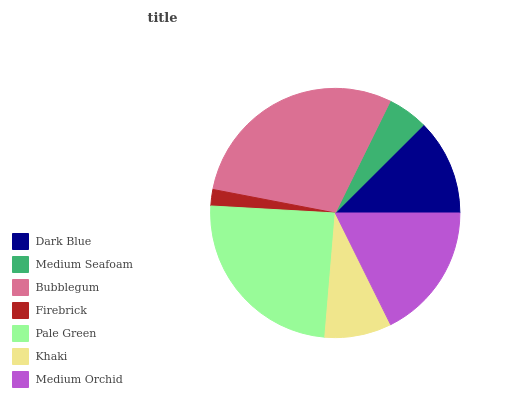Is Firebrick the minimum?
Answer yes or no. Yes. Is Bubblegum the maximum?
Answer yes or no. Yes. Is Medium Seafoam the minimum?
Answer yes or no. No. Is Medium Seafoam the maximum?
Answer yes or no. No. Is Dark Blue greater than Medium Seafoam?
Answer yes or no. Yes. Is Medium Seafoam less than Dark Blue?
Answer yes or no. Yes. Is Medium Seafoam greater than Dark Blue?
Answer yes or no. No. Is Dark Blue less than Medium Seafoam?
Answer yes or no. No. Is Dark Blue the high median?
Answer yes or no. Yes. Is Dark Blue the low median?
Answer yes or no. Yes. Is Firebrick the high median?
Answer yes or no. No. Is Medium Seafoam the low median?
Answer yes or no. No. 